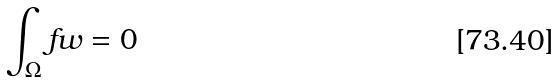<formula> <loc_0><loc_0><loc_500><loc_500>\int _ { \Omega } f w = 0</formula> 